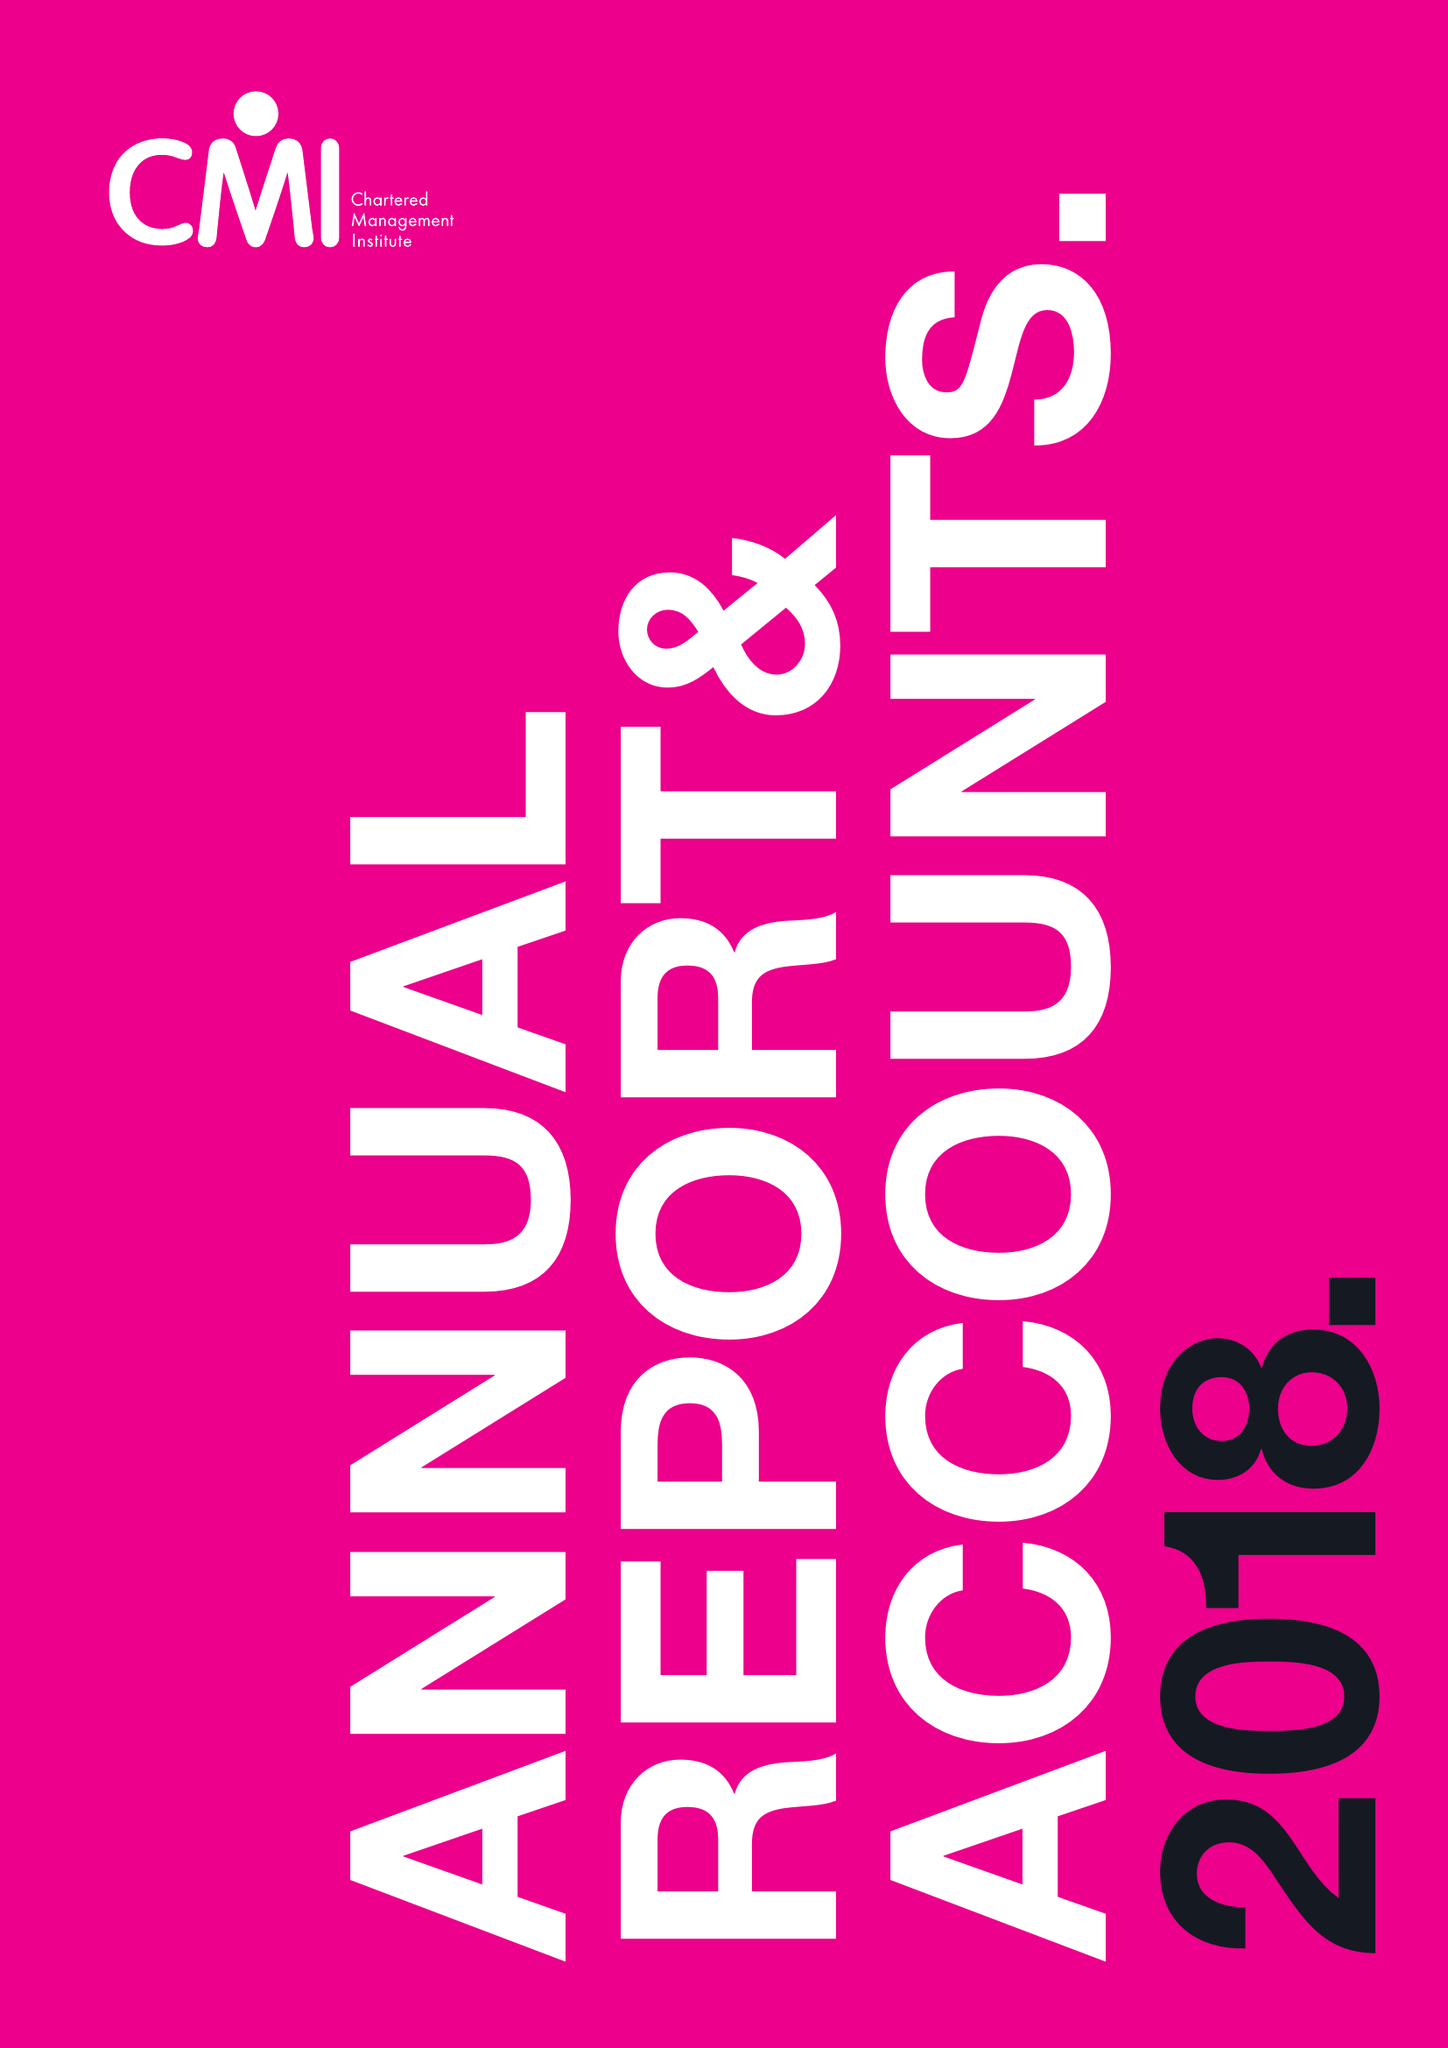What is the value for the charity_name?
Answer the question using a single word or phrase. Chartered Management Institute 